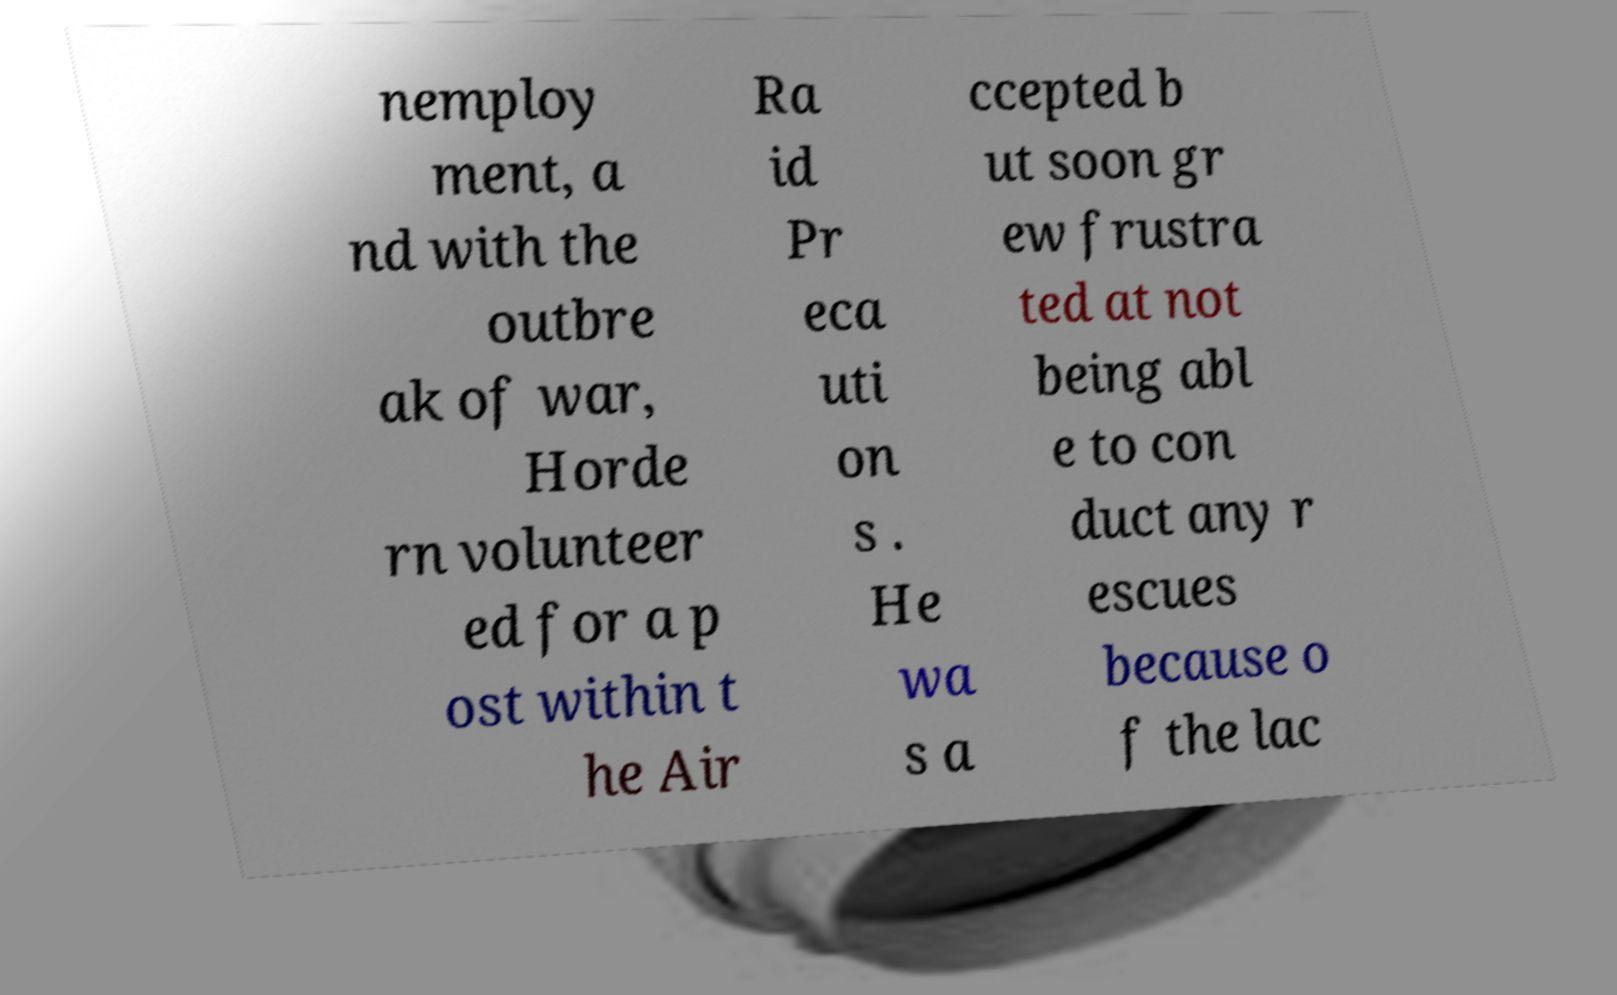Please identify and transcribe the text found in this image. nemploy ment, a nd with the outbre ak of war, Horde rn volunteer ed for a p ost within t he Air Ra id Pr eca uti on s . He wa s a ccepted b ut soon gr ew frustra ted at not being abl e to con duct any r escues because o f the lac 